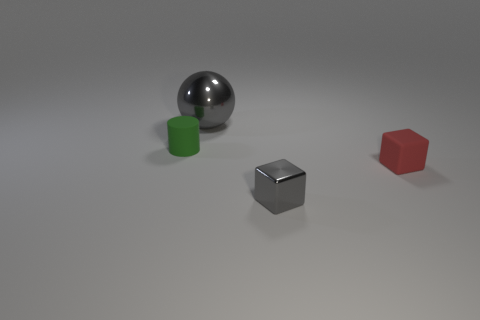Add 4 green matte things. How many objects exist? 8 Subtract all cylinders. How many objects are left? 3 Subtract 0 yellow cubes. How many objects are left? 4 Subtract all yellow cylinders. Subtract all tiny gray cubes. How many objects are left? 3 Add 3 big gray shiny spheres. How many big gray shiny spheres are left? 4 Add 2 big red metal objects. How many big red metal objects exist? 2 